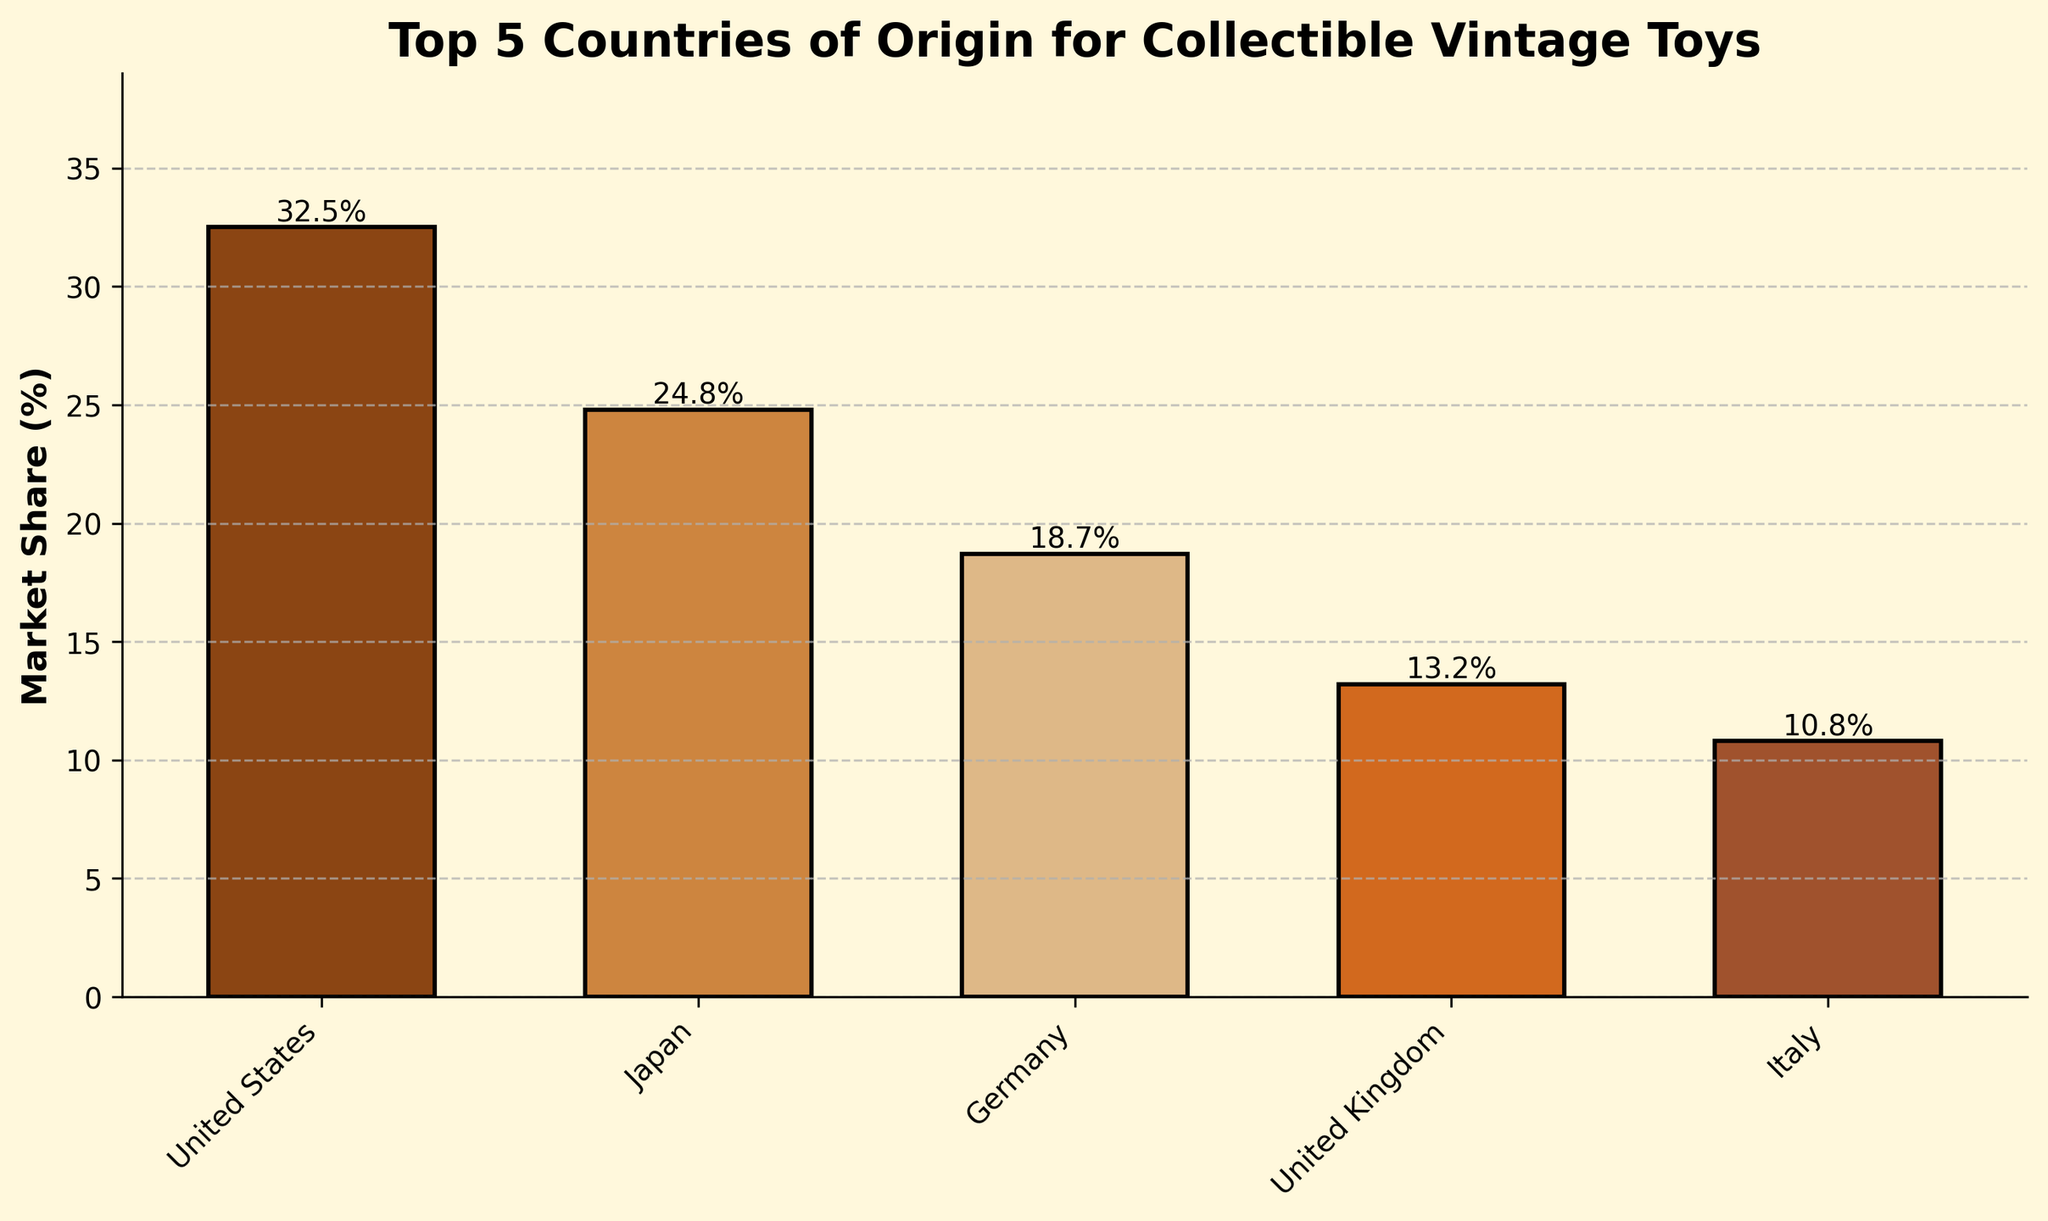Which country has the highest market share in collectible vintage toys? The country with the highest market share has the tallest bar in the bar chart. The United States has the tallest bar, indicating it has the highest market share.
Answer: United States Which country has the lowest market share in collectible vintage toys? The country with the lowest market share has the shortest bar in the bar chart. Italy has the shortest bar, indicating it has the lowest market share among the top 5 countries.
Answer: Italy What is the sum of market shares of the United Kingdom and Germany? The market share of the United Kingdom is 13.2%, and the market share of Germany is 18.7%. Adding these together gives 13.2% + 18.7% = 31.9%.
Answer: 31.9% How much higher is the market share of the United States compared to Japan? The market share of the United States is 32.5%, and the market share of Japan is 24.8%. Subtracting these gives 32.5% - 24.8% = 7.7%.
Answer: 7.7% Which country has a market share closest to 20%? The country whose market share is closest to 20% is determined by finding the country with a value nearest to 20%. Germany, with a market share of 18.7%, is closest to 20%.
Answer: Germany Rank the countries from highest to lowest market share. Based on the heights of the bars, the countries are ranked as follows: United States (32.5%), Japan (24.8%), Germany (18.7%), United Kingdom (13.2%), and Italy (10.8%).
Answer: United States, Japan, Germany, United Kingdom, Italy What is the average market share of all five countries? Add up the market shares of all five countries and divide by the number of countries. The sum is 32.5% + 24.8% + 18.7% + 13.2% + 10.8% = 100%, and the average is 100% / 5 = 20%.
Answer: 20% What color represents the bar with the third highest market share? The bar with the third highest market share corresponds to Germany. The color assigned to Germany is the third bar from the left, which is brown (indicated by the color resembling '#DEB887').
Answer: Brown 